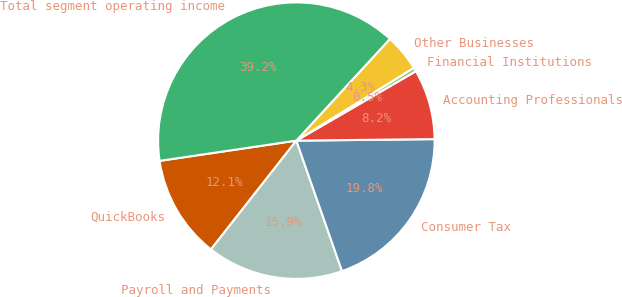<chart> <loc_0><loc_0><loc_500><loc_500><pie_chart><fcel>QuickBooks<fcel>Payroll and Payments<fcel>Consumer Tax<fcel>Accounting Professionals<fcel>Financial Institutions<fcel>Other Businesses<fcel>Total segment operating income<nl><fcel>12.07%<fcel>15.95%<fcel>19.82%<fcel>8.2%<fcel>0.46%<fcel>4.33%<fcel>39.18%<nl></chart> 